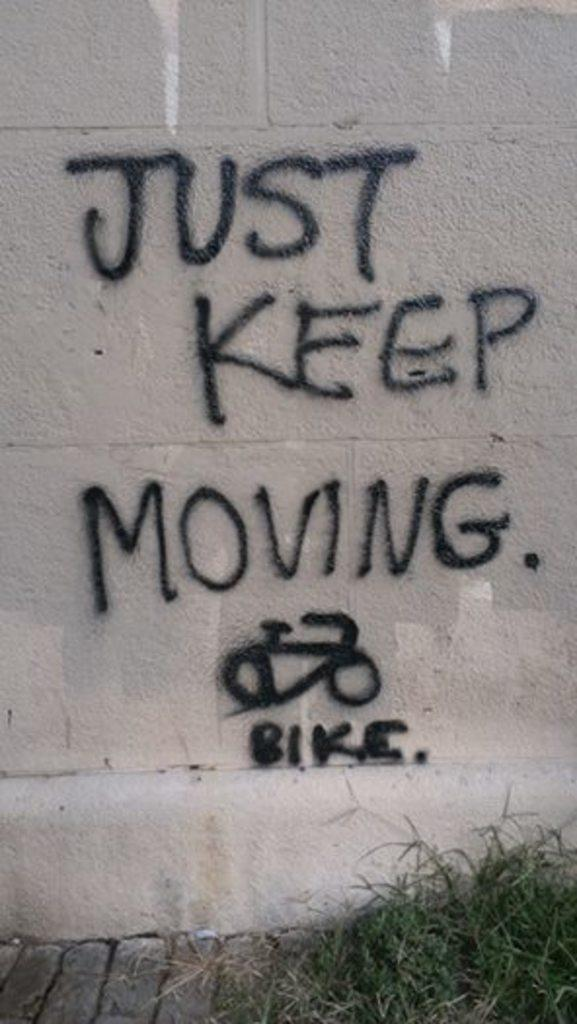What is present on the wall in the image? There is writing on the wall in the image. What type of surface can be seen in the image? There is a wall and grass visible in the image. What is the aftermath of the volleyball game in the image? There is no volleyball game or aftermath present in the image; it only features a wall with writing and grass. What type of surface is the sidewalk in the image? There is no sidewalk present in the image; it only features a wall with writing and grass. 